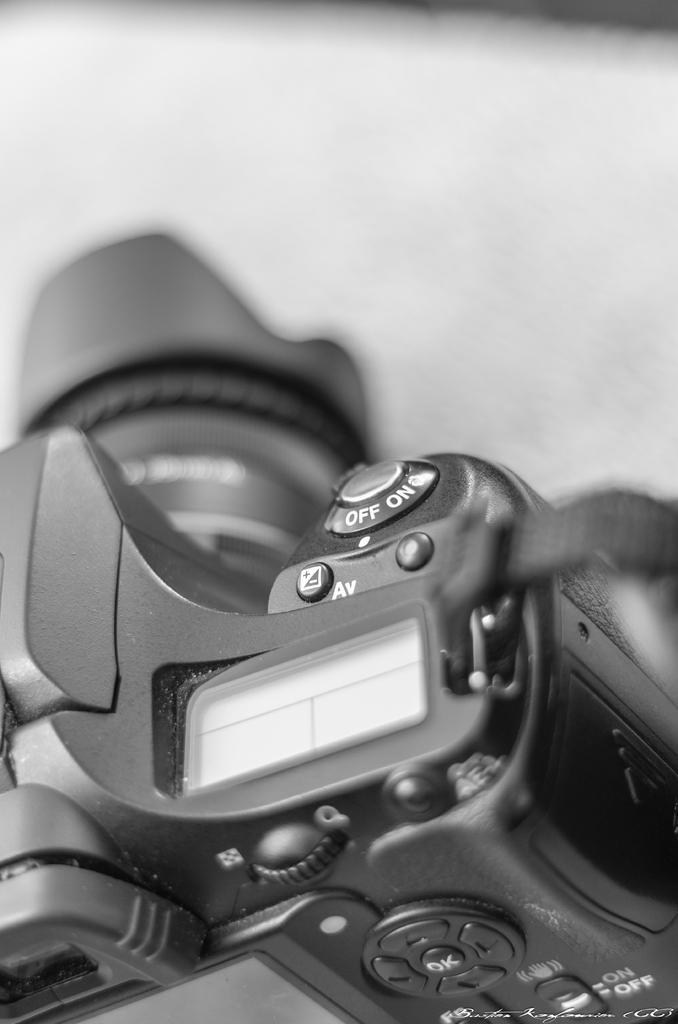Could you give a brief overview of what you see in this image? In this image at the bottom there is a camera, and on the top of the image there is table. 